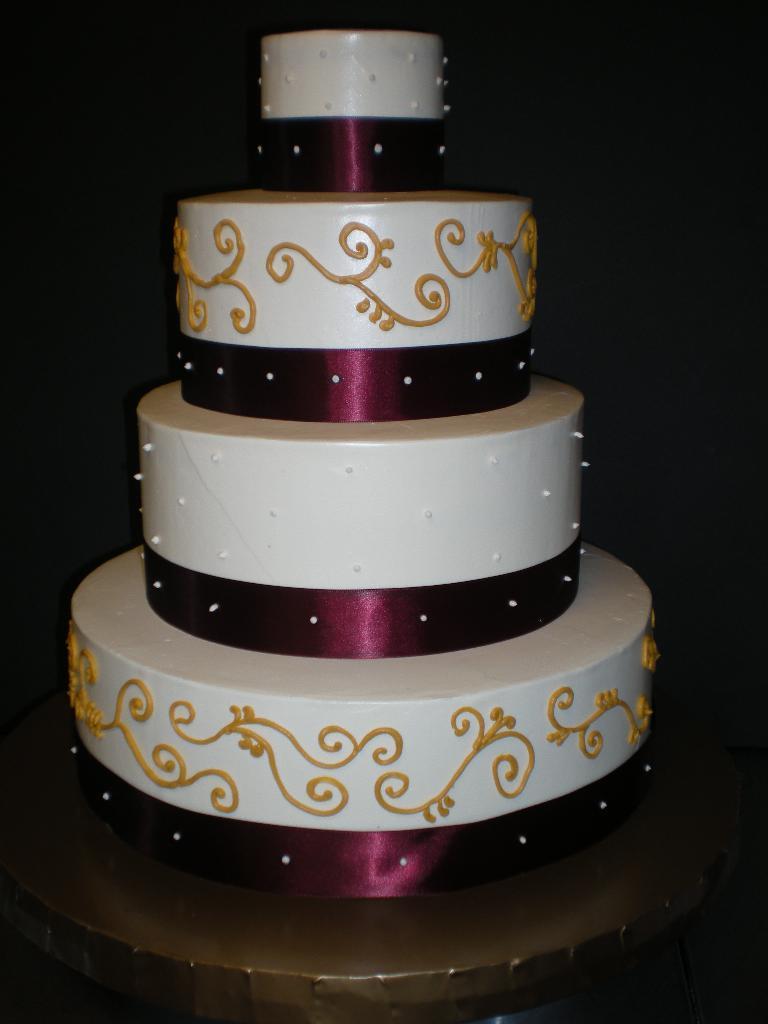Can you describe this image briefly? This is a picture of a cake, on the cake there is a violet color ribbon. The background is dark. 